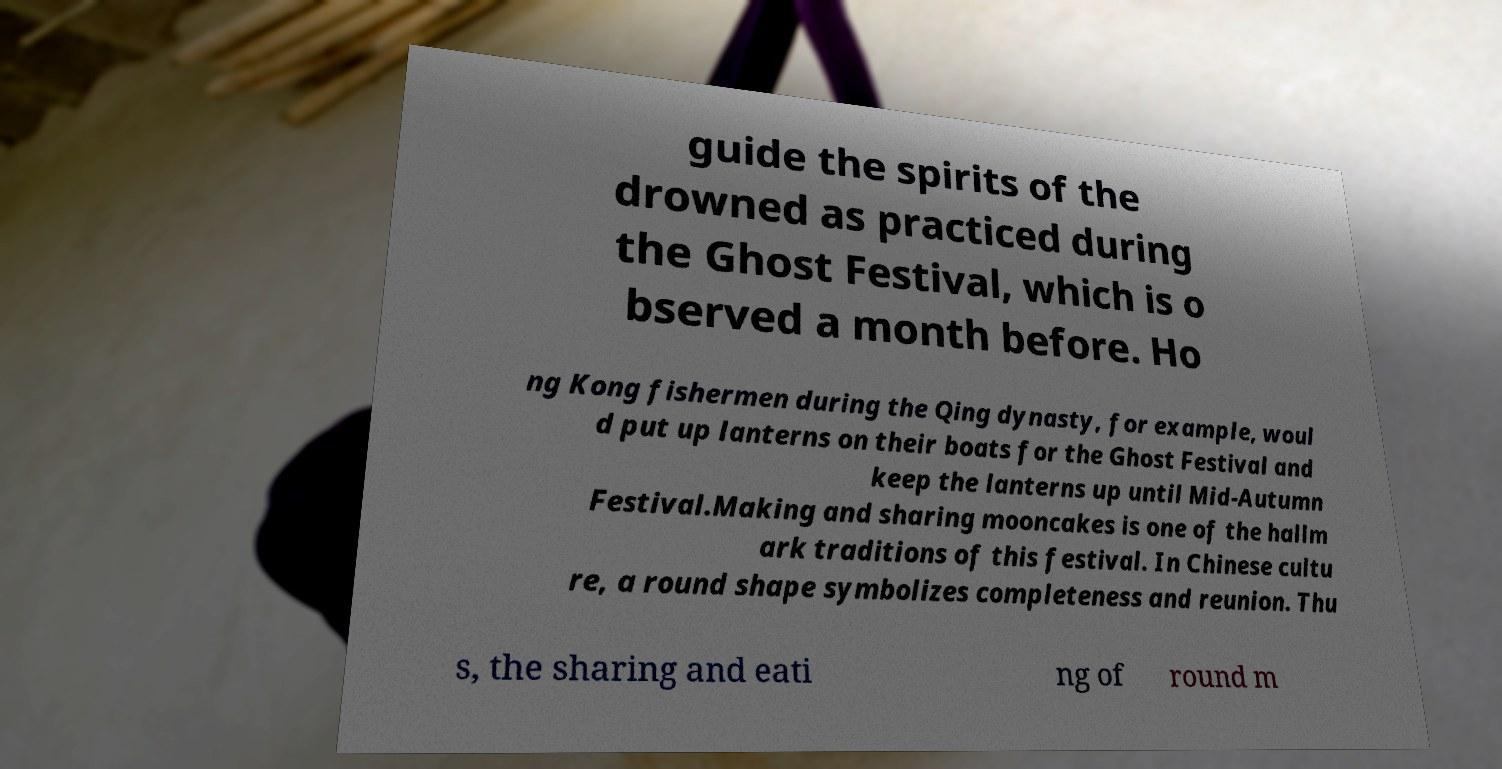Can you accurately transcribe the text from the provided image for me? guide the spirits of the drowned as practiced during the Ghost Festival, which is o bserved a month before. Ho ng Kong fishermen during the Qing dynasty, for example, woul d put up lanterns on their boats for the Ghost Festival and keep the lanterns up until Mid-Autumn Festival.Making and sharing mooncakes is one of the hallm ark traditions of this festival. In Chinese cultu re, a round shape symbolizes completeness and reunion. Thu s, the sharing and eati ng of round m 